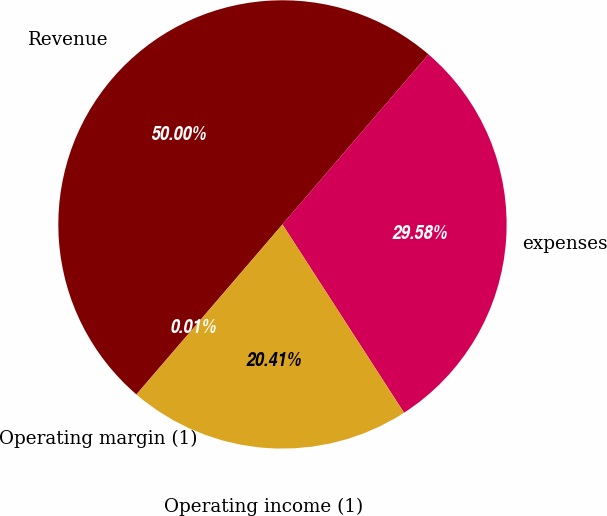Convert chart to OTSL. <chart><loc_0><loc_0><loc_500><loc_500><pie_chart><fcel>Revenue<fcel>expenses<fcel>Operating income (1)<fcel>Operating margin (1)<nl><fcel>49.99%<fcel>29.58%<fcel>20.41%<fcel>0.01%<nl></chart> 